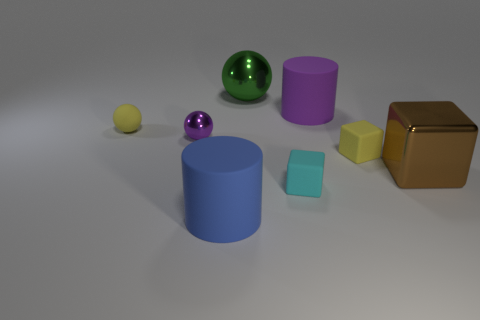Add 1 shiny cubes. How many objects exist? 9 Subtract all cylinders. How many objects are left? 6 Subtract all small yellow balls. Subtract all blue rubber things. How many objects are left? 6 Add 8 tiny spheres. How many tiny spheres are left? 10 Add 4 purple cylinders. How many purple cylinders exist? 5 Subtract 1 purple cylinders. How many objects are left? 7 